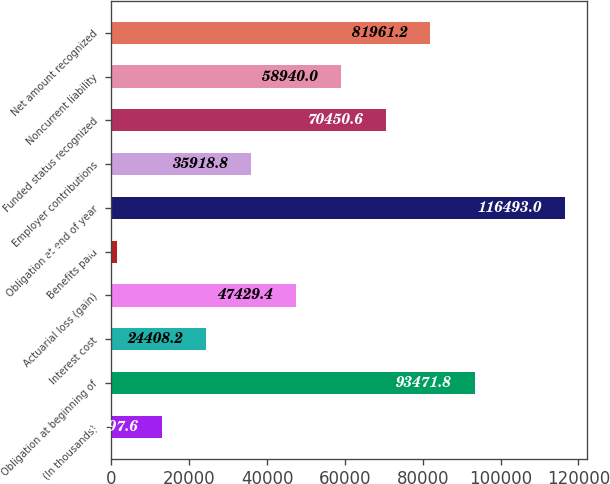<chart> <loc_0><loc_0><loc_500><loc_500><bar_chart><fcel>(In thousands)<fcel>Obligation at beginning of<fcel>Interest cost<fcel>Actuarial loss (gain)<fcel>Benefits paid<fcel>Obligation at end of year<fcel>Employer contributions<fcel>Funded status recognized<fcel>Noncurrent liability<fcel>Net amount recognized<nl><fcel>12897.6<fcel>93471.8<fcel>24408.2<fcel>47429.4<fcel>1387<fcel>116493<fcel>35918.8<fcel>70450.6<fcel>58940<fcel>81961.2<nl></chart> 